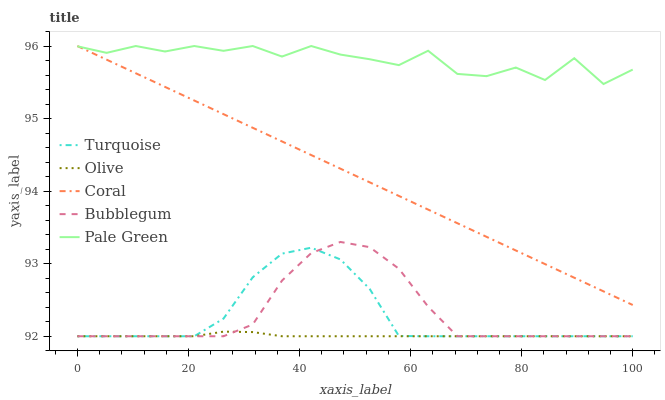Does Turquoise have the minimum area under the curve?
Answer yes or no. No. Does Turquoise have the maximum area under the curve?
Answer yes or no. No. Is Turquoise the smoothest?
Answer yes or no. No. Is Turquoise the roughest?
Answer yes or no. No. Does Pale Green have the lowest value?
Answer yes or no. No. Does Turquoise have the highest value?
Answer yes or no. No. Is Bubblegum less than Pale Green?
Answer yes or no. Yes. Is Coral greater than Turquoise?
Answer yes or no. Yes. Does Bubblegum intersect Pale Green?
Answer yes or no. No. 